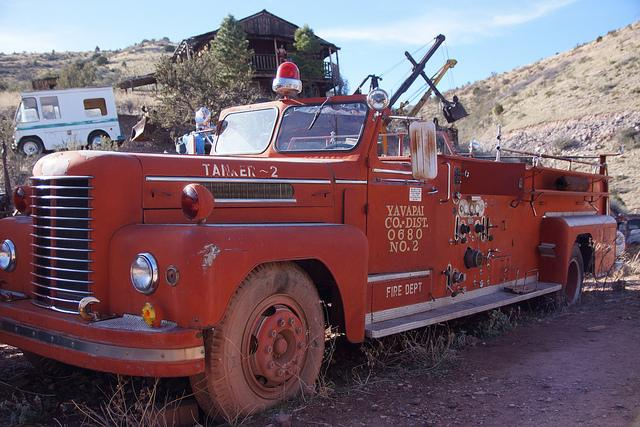What sort of emergency is the truck seen here prepared to immediately handle? fire 